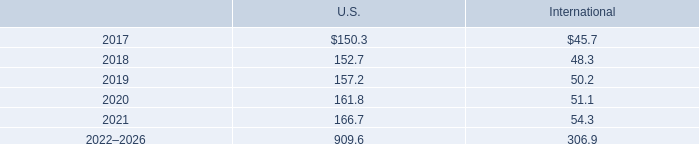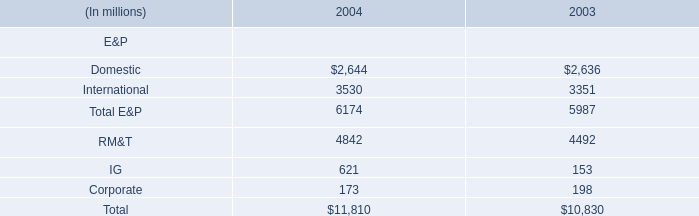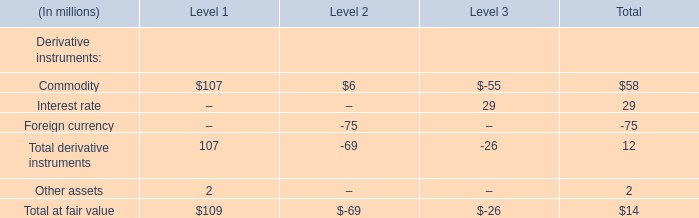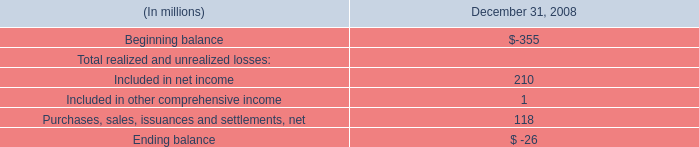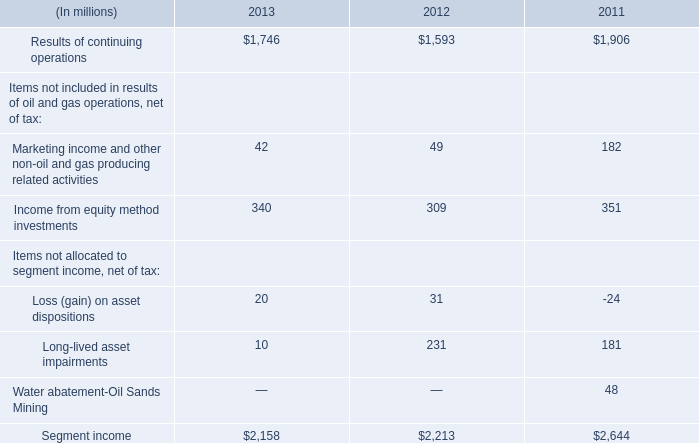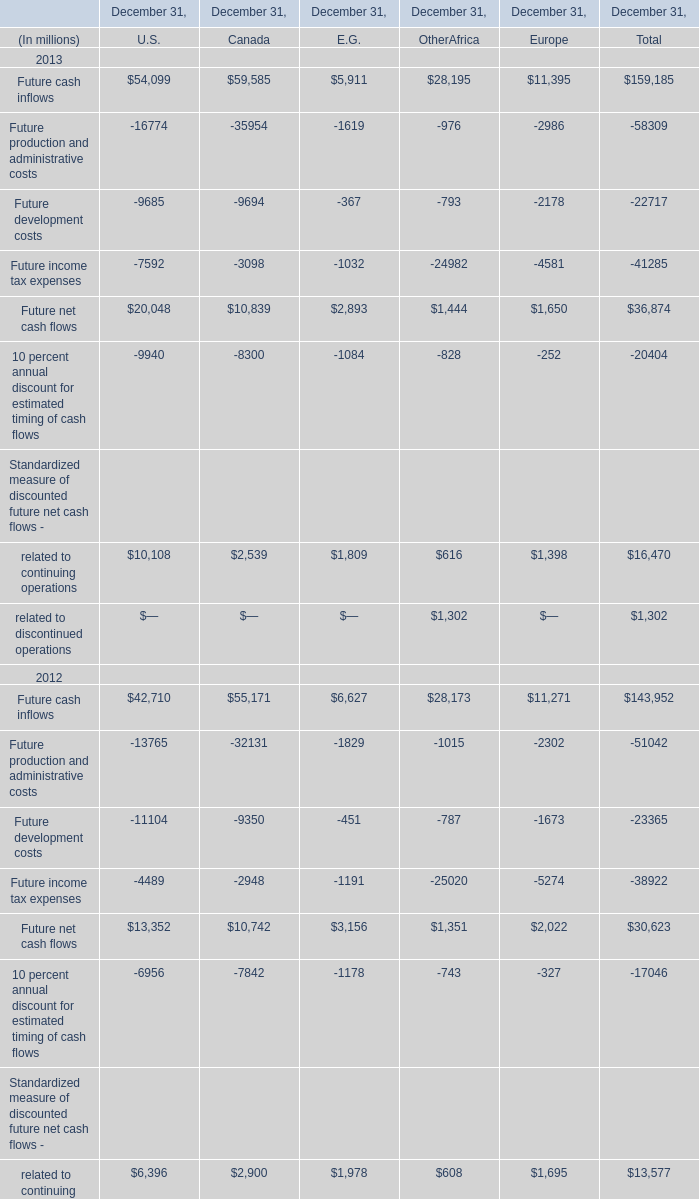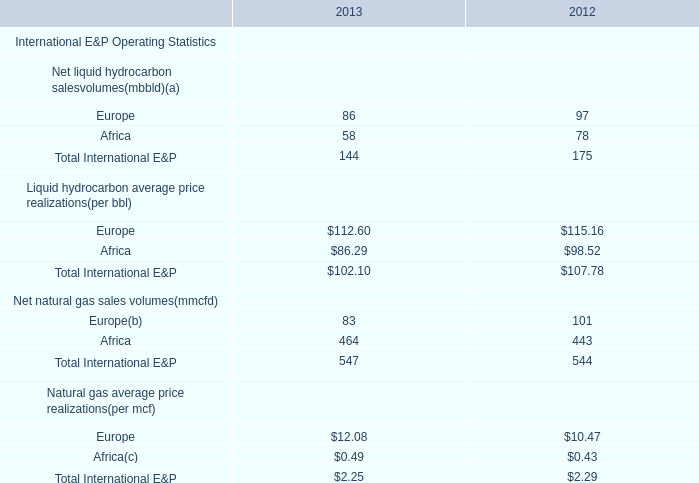What is the sum of Future income tax expenses 2011 of December 31, Canada, Results of continuing operations of 2013, and Domestic of 2004 ? 
Computations: ((4490.0 + 1746.0) + 2644.0)
Answer: 8880.0. 